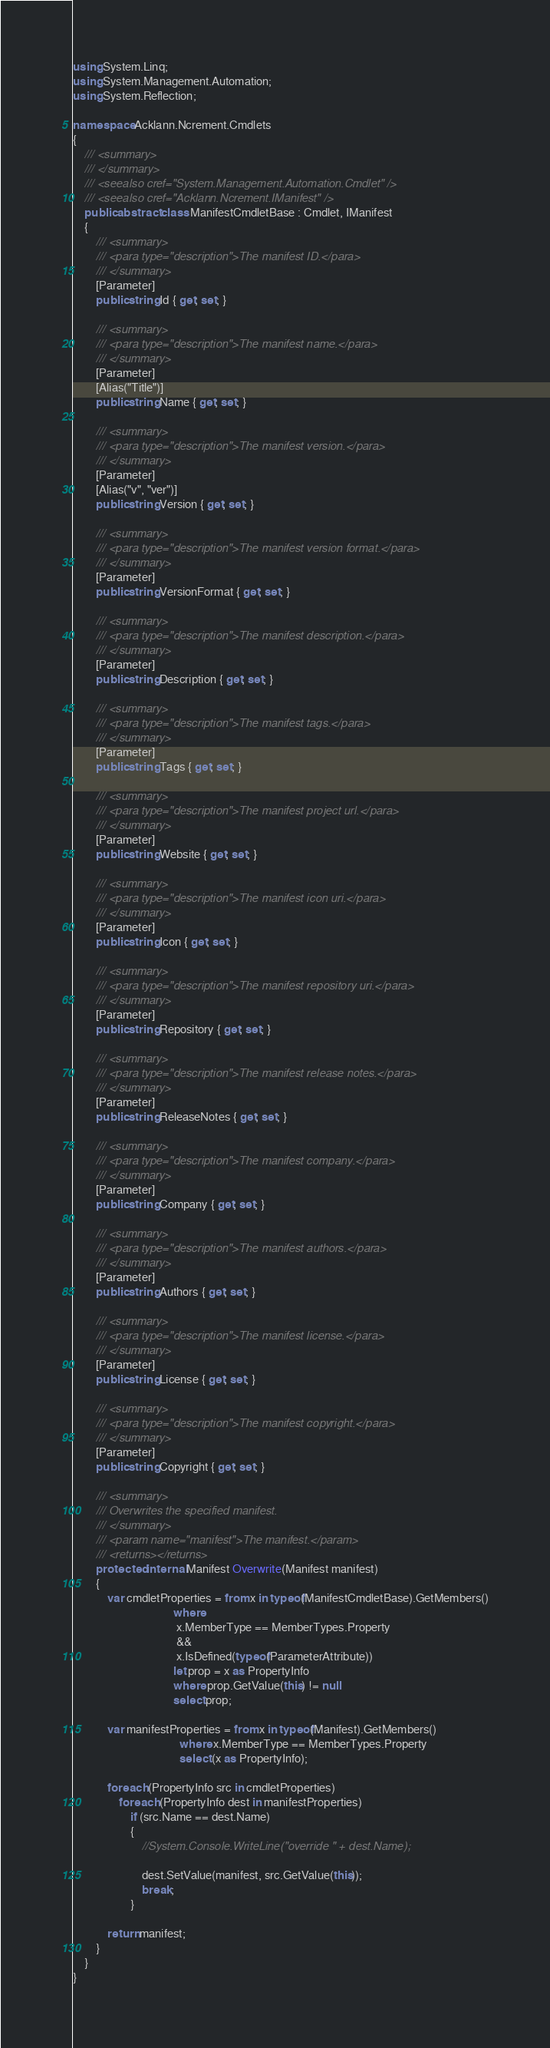<code> <loc_0><loc_0><loc_500><loc_500><_C#_>using System.Linq;
using System.Management.Automation;
using System.Reflection;

namespace Acklann.Ncrement.Cmdlets
{
    /// <summary>
    /// </summary>
    /// <seealso cref="System.Management.Automation.Cmdlet" />
    /// <seealso cref="Acklann.Ncrement.IManifest" />
    public abstract class ManifestCmdletBase : Cmdlet, IManifest
    {
        /// <summary>
        /// <para type="description">The manifest ID.</para>
        /// </summary>
        [Parameter]
        public string Id { get; set; }

        /// <summary>
        /// <para type="description">The manifest name.</para>
        /// </summary>
        [Parameter]
        [Alias("Title")]
        public string Name { get; set; }

        /// <summary>
        /// <para type="description">The manifest version.</para>
        /// </summary>
        [Parameter]
        [Alias("v", "ver")]
        public string Version { get; set; }

        /// <summary>
        /// <para type="description">The manifest version format.</para>
        /// </summary>
        [Parameter]
        public string VersionFormat { get; set; }

        /// <summary>
        /// <para type="description">The manifest description.</para>
        /// </summary>
        [Parameter]
        public string Description { get; set; }

        /// <summary>
        /// <para type="description">The manifest tags.</para>
        /// </summary>
        [Parameter]
        public string Tags { get; set; }

        /// <summary>
        /// <para type="description">The manifest project url.</para>
        /// </summary>
        [Parameter]
        public string Website { get; set; }

        /// <summary>
        /// <para type="description">The manifest icon uri.</para>
        /// </summary>
        [Parameter]
        public string Icon { get; set; }

        /// <summary>
        /// <para type="description">The manifest repository uri.</para>
        /// </summary>
        [Parameter]
        public string Repository { get; set; }

        /// <summary>
        /// <para type="description">The manifest release notes.</para>
        /// </summary>
        [Parameter]
        public string ReleaseNotes { get; set; }

        /// <summary>
        /// <para type="description">The manifest company.</para>
        /// </summary>
        [Parameter]
        public string Company { get; set; }

        /// <summary>
        /// <para type="description">The manifest authors.</para>
        /// </summary>
        [Parameter]
        public string Authors { get; set; }

        /// <summary>
        /// <para type="description">The manifest license.</para>
        /// </summary>
        [Parameter]
        public string License { get; set; }

        /// <summary>
        /// <para type="description">The manifest copyright.</para>
        /// </summary>
        [Parameter]
        public string Copyright { get; set; }

        /// <summary>
        /// Overwrites the specified manifest.
        /// </summary>
        /// <param name="manifest">The manifest.</param>
        /// <returns></returns>
        protected internal Manifest Overwrite(Manifest manifest)
        {
            var cmdletProperties = from x in typeof(ManifestCmdletBase).GetMembers()
                                   where
                                    x.MemberType == MemberTypes.Property
                                    &&
                                    x.IsDefined(typeof(ParameterAttribute))
                                   let prop = x as PropertyInfo
                                   where prop.GetValue(this) != null
                                   select prop;

            var manifestProperties = from x in typeof(Manifest).GetMembers()
                                     where x.MemberType == MemberTypes.Property
                                     select (x as PropertyInfo);

            foreach (PropertyInfo src in cmdletProperties)
                foreach (PropertyInfo dest in manifestProperties)
                    if (src.Name == dest.Name)
                    {
                        //System.Console.WriteLine("override " + dest.Name);

                        dest.SetValue(manifest, src.GetValue(this));
                        break;
                    }

            return manifest;
        }
    }
}</code> 